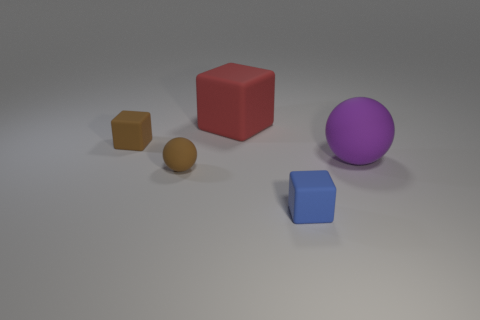Add 4 big matte objects. How many objects exist? 9 Subtract all balls. How many objects are left? 3 Add 3 big red cubes. How many big red cubes exist? 4 Subtract 0 purple cylinders. How many objects are left? 5 Subtract all big rubber things. Subtract all tiny brown matte cylinders. How many objects are left? 3 Add 4 large rubber cubes. How many large rubber cubes are left? 5 